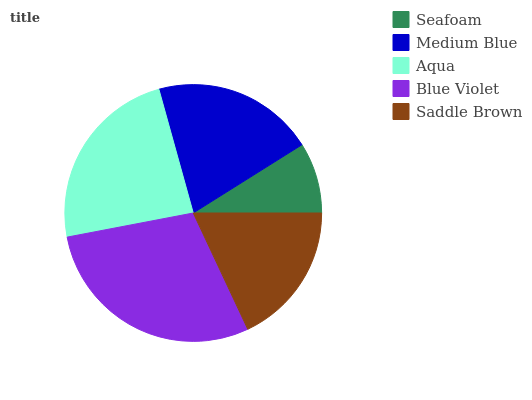Is Seafoam the minimum?
Answer yes or no. Yes. Is Blue Violet the maximum?
Answer yes or no. Yes. Is Medium Blue the minimum?
Answer yes or no. No. Is Medium Blue the maximum?
Answer yes or no. No. Is Medium Blue greater than Seafoam?
Answer yes or no. Yes. Is Seafoam less than Medium Blue?
Answer yes or no. Yes. Is Seafoam greater than Medium Blue?
Answer yes or no. No. Is Medium Blue less than Seafoam?
Answer yes or no. No. Is Medium Blue the high median?
Answer yes or no. Yes. Is Medium Blue the low median?
Answer yes or no. Yes. Is Aqua the high median?
Answer yes or no. No. Is Saddle Brown the low median?
Answer yes or no. No. 